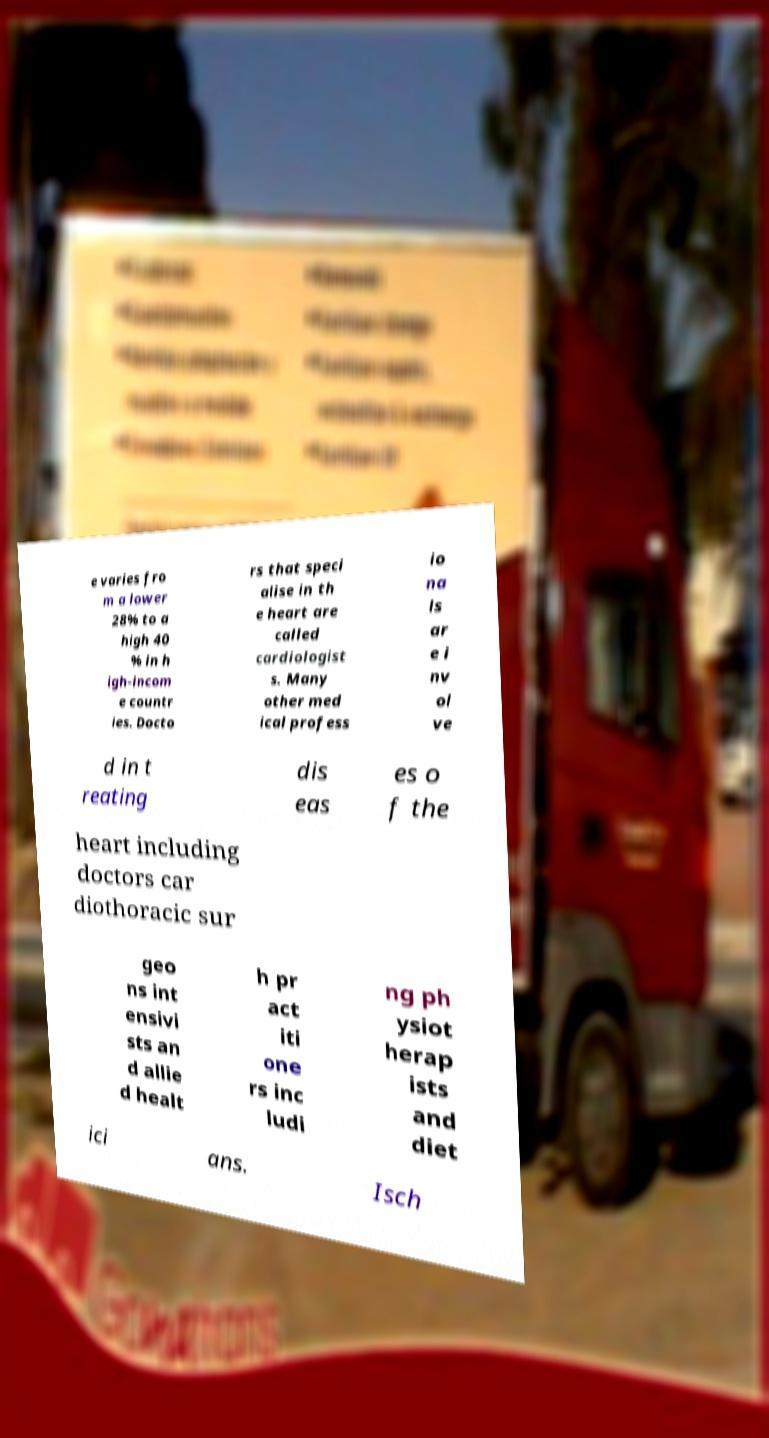For documentation purposes, I need the text within this image transcribed. Could you provide that? e varies fro m a lower 28% to a high 40 % in h igh-incom e countr ies. Docto rs that speci alise in th e heart are called cardiologist s. Many other med ical profess io na ls ar e i nv ol ve d in t reating dis eas es o f the heart including doctors car diothoracic sur geo ns int ensivi sts an d allie d healt h pr act iti one rs inc ludi ng ph ysiot herap ists and diet ici ans. Isch 